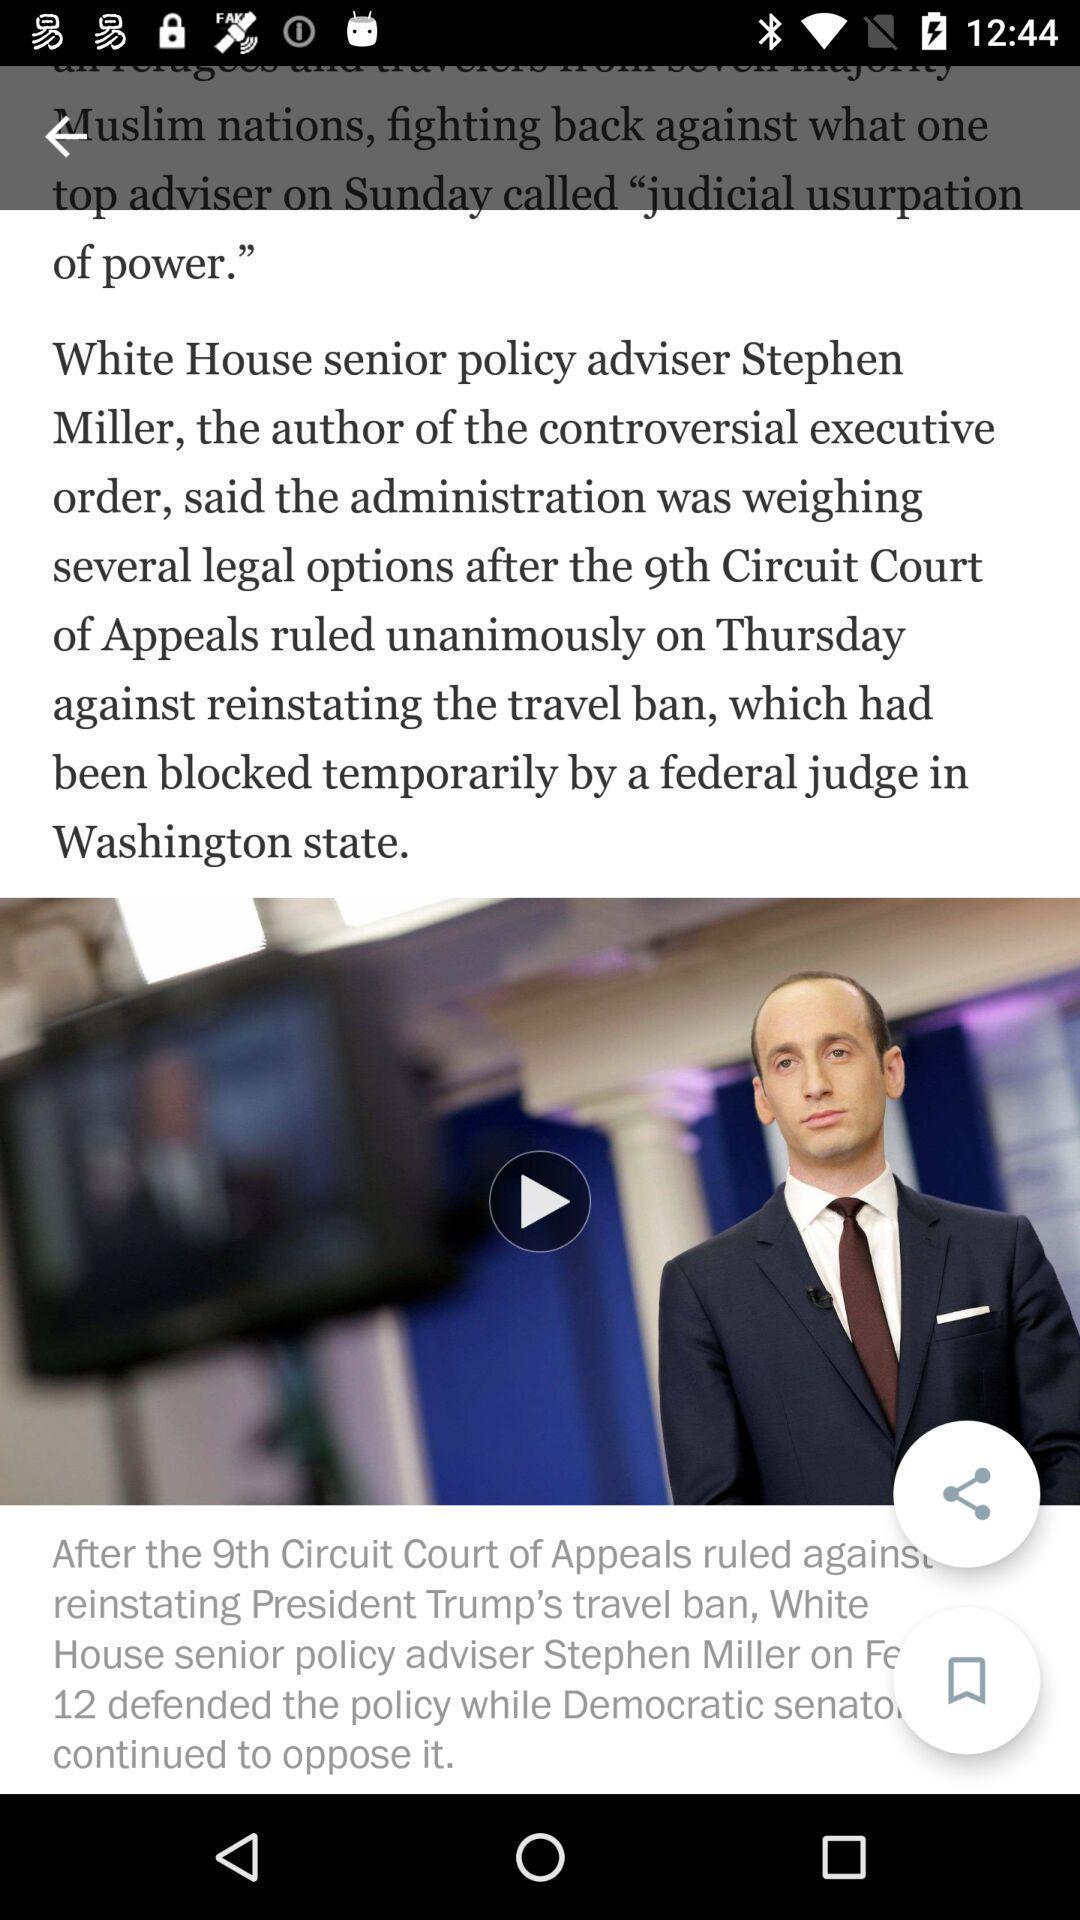Explain the elements present in this screenshot. Screen displaying information about a news article. 